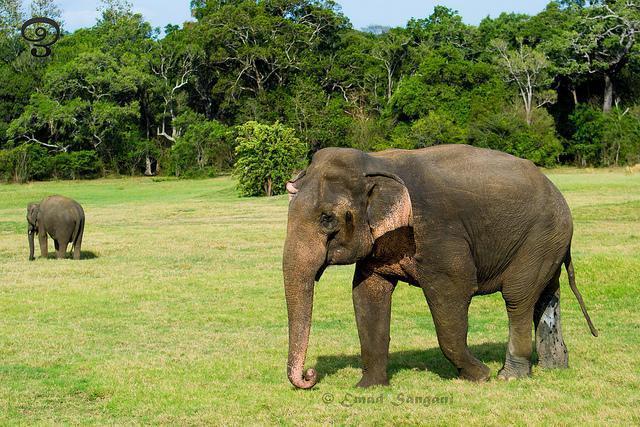How many elephants are visible?
Give a very brief answer. 2. 